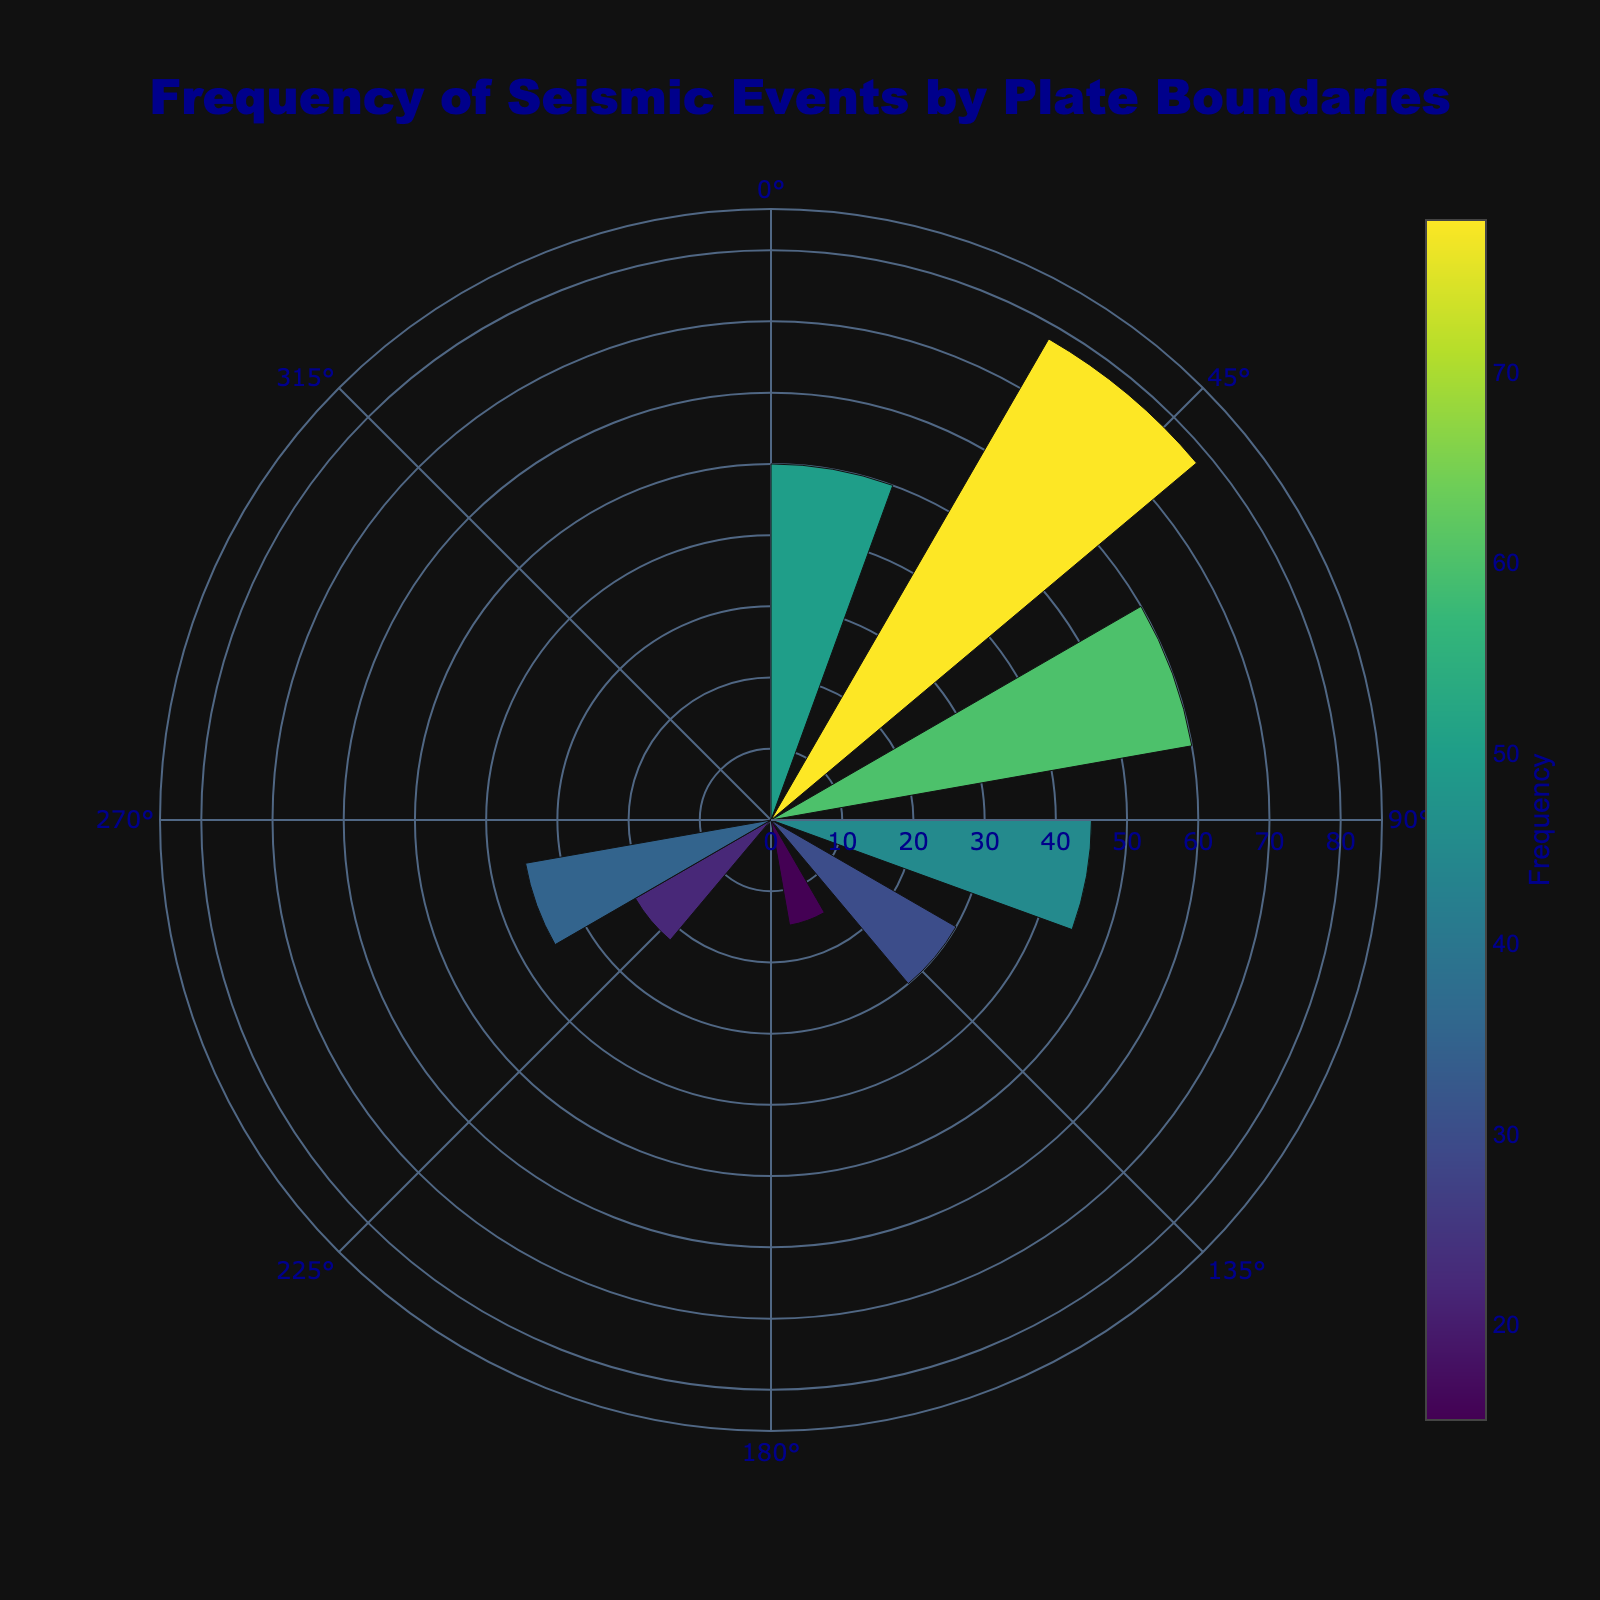What is the title of the chart? The title of the chart is displayed at the top of the figure, typically in a larger font size. In this case, it is "Frequency of Seismic Events by Plate Boundaries".
Answer: Frequency of Seismic Events by Plate Boundaries What is the azimuth value for the Eurasian-Arabian plate boundary? To find the azimuth value for the Eurasian-Arabian plate boundary, look for this boundary in the hover text or directly in the figure. The azimuth is listed as 250°.
Answer: 250° Which plate boundary has the highest seismic event frequency and what is its frequency? To determine the plate boundary with the highest seismic event frequency, look for the largest bar in the rose chart or the highest value in the color scale. The Pacific-North_American boundary has the highest frequency of 78.
Answer: Pacific-North_American, 78 How many plate boundaries have a seismic event frequency of over 50? Count the number of plate boundaries with bars extending beyond the 50 mark on the radial axis of the rose chart. The plate boundaries are Pacific-North_American, Nazca-South_American, and Indian-Eurasian.
Answer: 3 What is the combined seismic event frequency for the Pacific-Australian and Eurasian-Philippine plate boundaries? Add the seismic event frequencies for Pacific-Australian (45) and Eurasian-Philippine (30). The combined frequency is 45 + 30 = 75.
Answer: 75 Which plate boundary has the lowest seismic event frequency and what is its frequency? Identify the smallest bar in the rose chart. The Pacific-Antarctic plate boundary has the lowest frequency of 15.
Answer: Pacific-Antarctic, 15 What is the range of frequencies depicted in the chart? Determine the smallest and largest seismic event frequencies from the bars in the rose chart. The range is from 15 to 78.
Answer: 15 to 78 How does the seismic event frequency of the Indian-Eurasian plate boundary compare to that of the Pacific-Australian plate boundary? Compare the heights of the bars or the values in the hover text. The Indian-Eurasian plate boundary has a frequency of 50, whereas the Pacific-Australian has 45. Since 50 is greater than 45, the Indian-Eurasian has a higher frequency.
Answer: Indian-Eurasian is higher What is the average seismic event frequency of all the plate boundaries? Sum up all the seismic event frequencies (45 + 78 + 30 + 60 + 22 + 35 + 50 + 15 = 335) and divide by the number of plate boundaries (8). The average is 335 / 8 = 41.88.
Answer: 41.88 What color represents the highest frequency in the chart? The color representing the highest frequency can be identified by looking at the color scale. The highest frequency (78) uses the color at the top of the Viridis color scale, which is typically yellow-green.
Answer: Yellow-green 